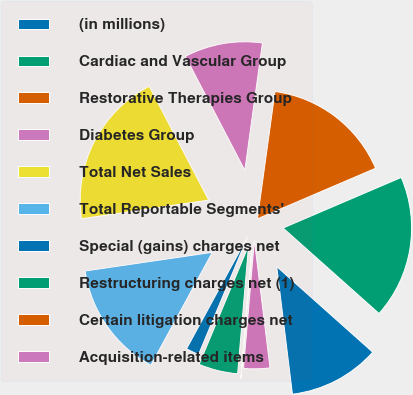<chart> <loc_0><loc_0><loc_500><loc_500><pie_chart><fcel>(in millions)<fcel>Cardiac and Vascular Group<fcel>Restorative Therapies Group<fcel>Diabetes Group<fcel>Total Net Sales<fcel>Total Reportable Segments'<fcel>Special (gains) charges net<fcel>Restructuring charges net (1)<fcel>Certain litigation charges net<fcel>Acquisition-related items<nl><fcel>11.47%<fcel>18.02%<fcel>16.38%<fcel>9.84%<fcel>19.66%<fcel>14.75%<fcel>1.65%<fcel>4.93%<fcel>0.01%<fcel>3.29%<nl></chart> 